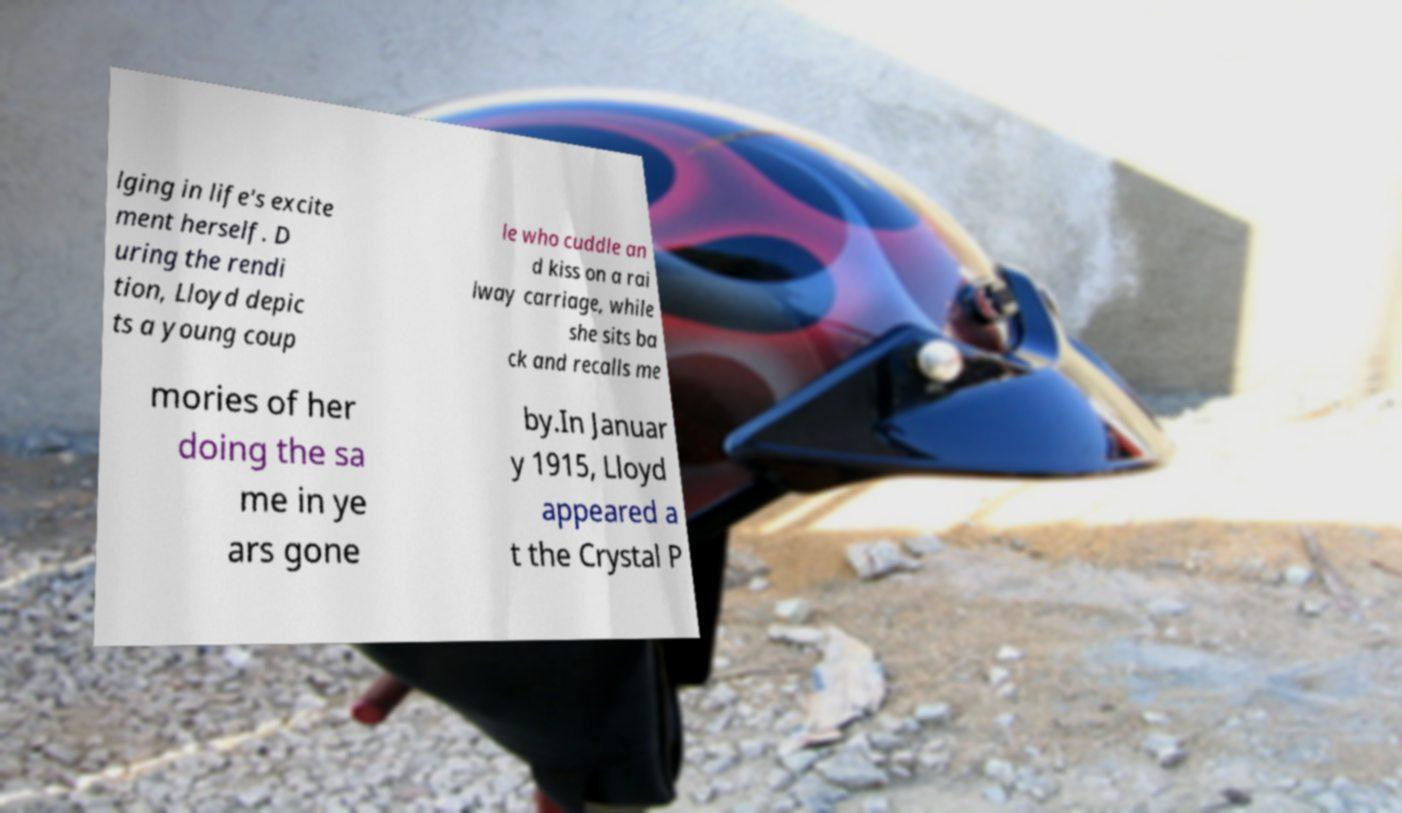Can you read and provide the text displayed in the image?This photo seems to have some interesting text. Can you extract and type it out for me? lging in life's excite ment herself. D uring the rendi tion, Lloyd depic ts a young coup le who cuddle an d kiss on a rai lway carriage, while she sits ba ck and recalls me mories of her doing the sa me in ye ars gone by.In Januar y 1915, Lloyd appeared a t the Crystal P 